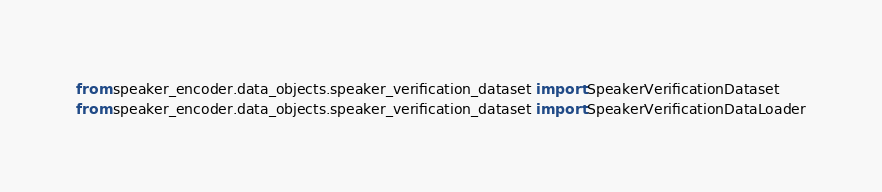<code> <loc_0><loc_0><loc_500><loc_500><_Python_>from speaker_encoder.data_objects.speaker_verification_dataset import SpeakerVerificationDataset
from speaker_encoder.data_objects.speaker_verification_dataset import SpeakerVerificationDataLoader
</code> 